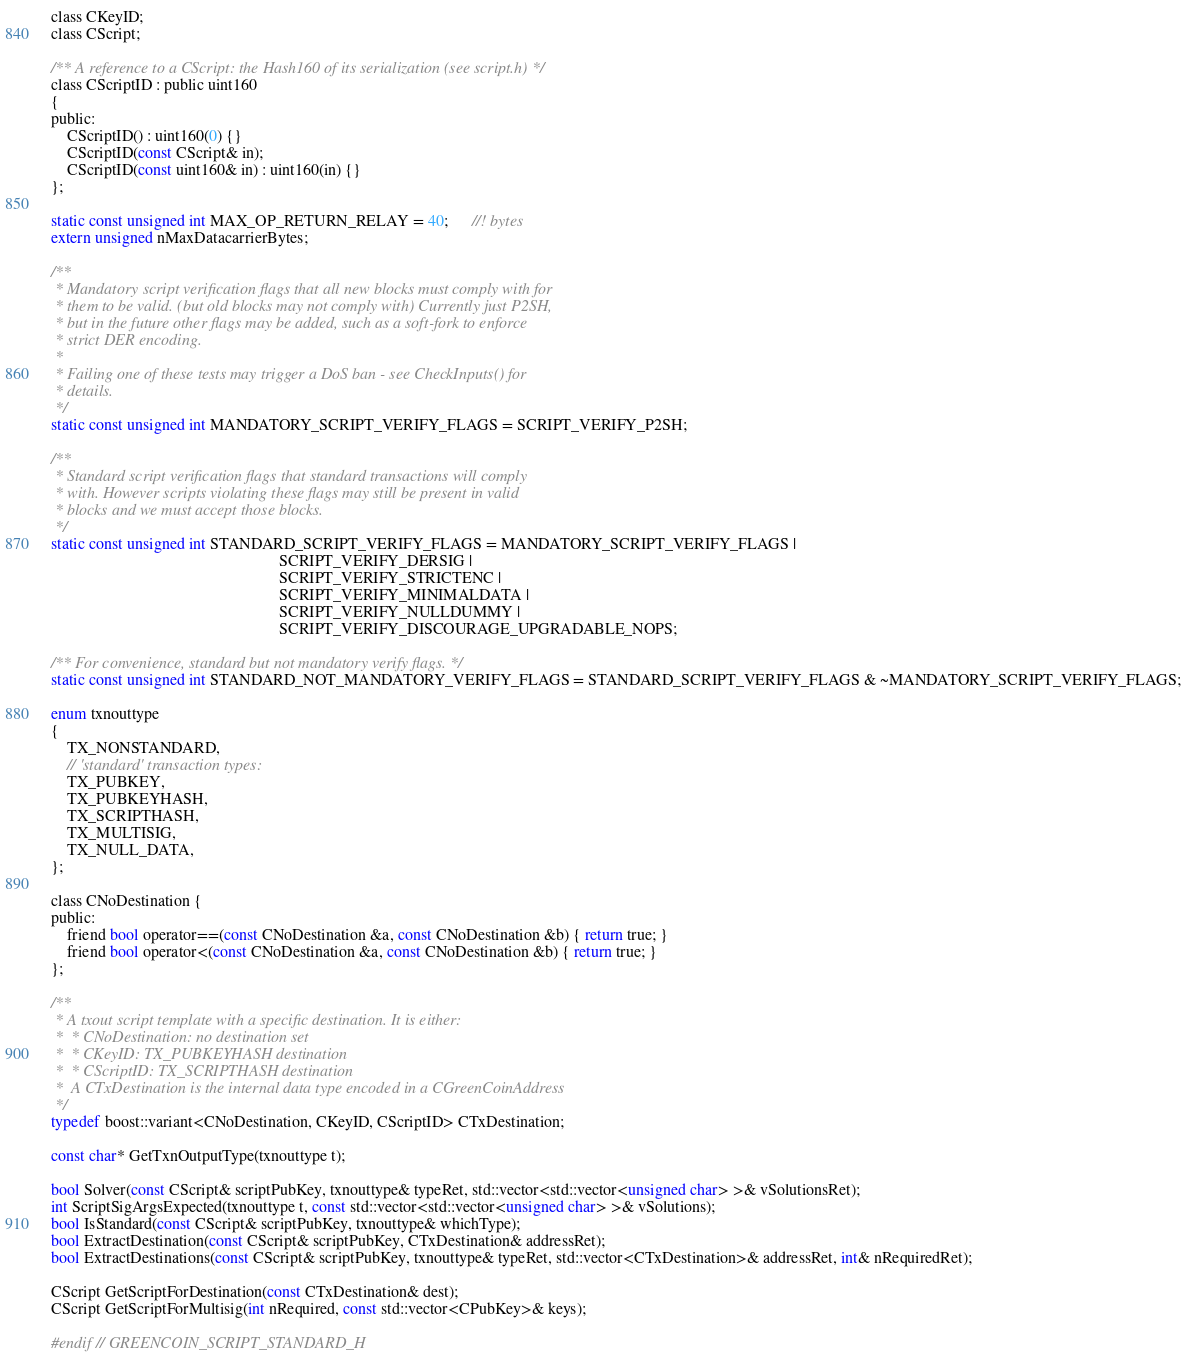Convert code to text. <code><loc_0><loc_0><loc_500><loc_500><_C_>
class CKeyID;
class CScript;

/** A reference to a CScript: the Hash160 of its serialization (see script.h) */
class CScriptID : public uint160
{
public:
    CScriptID() : uint160(0) {}
    CScriptID(const CScript& in);
    CScriptID(const uint160& in) : uint160(in) {}
};

static const unsigned int MAX_OP_RETURN_RELAY = 40;      //! bytes
extern unsigned nMaxDatacarrierBytes;

/**
 * Mandatory script verification flags that all new blocks must comply with for
 * them to be valid. (but old blocks may not comply with) Currently just P2SH,
 * but in the future other flags may be added, such as a soft-fork to enforce
 * strict DER encoding.
 * 
 * Failing one of these tests may trigger a DoS ban - see CheckInputs() for
 * details.
 */
static const unsigned int MANDATORY_SCRIPT_VERIFY_FLAGS = SCRIPT_VERIFY_P2SH;

/**
 * Standard script verification flags that standard transactions will comply
 * with. However scripts violating these flags may still be present in valid
 * blocks and we must accept those blocks.
 */
static const unsigned int STANDARD_SCRIPT_VERIFY_FLAGS = MANDATORY_SCRIPT_VERIFY_FLAGS |
                                                         SCRIPT_VERIFY_DERSIG |
                                                         SCRIPT_VERIFY_STRICTENC |
                                                         SCRIPT_VERIFY_MINIMALDATA |
                                                         SCRIPT_VERIFY_NULLDUMMY |
                                                         SCRIPT_VERIFY_DISCOURAGE_UPGRADABLE_NOPS;

/** For convenience, standard but not mandatory verify flags. */
static const unsigned int STANDARD_NOT_MANDATORY_VERIFY_FLAGS = STANDARD_SCRIPT_VERIFY_FLAGS & ~MANDATORY_SCRIPT_VERIFY_FLAGS;

enum txnouttype
{
    TX_NONSTANDARD,
    // 'standard' transaction types:
    TX_PUBKEY,
    TX_PUBKEYHASH,
    TX_SCRIPTHASH,
    TX_MULTISIG,
    TX_NULL_DATA,
};

class CNoDestination {
public:
    friend bool operator==(const CNoDestination &a, const CNoDestination &b) { return true; }
    friend bool operator<(const CNoDestination &a, const CNoDestination &b) { return true; }
};

/** 
 * A txout script template with a specific destination. It is either:
 *  * CNoDestination: no destination set
 *  * CKeyID: TX_PUBKEYHASH destination
 *  * CScriptID: TX_SCRIPTHASH destination
 *  A CTxDestination is the internal data type encoded in a CGreenCoinAddress
 */
typedef boost::variant<CNoDestination, CKeyID, CScriptID> CTxDestination;

const char* GetTxnOutputType(txnouttype t);

bool Solver(const CScript& scriptPubKey, txnouttype& typeRet, std::vector<std::vector<unsigned char> >& vSolutionsRet);
int ScriptSigArgsExpected(txnouttype t, const std::vector<std::vector<unsigned char> >& vSolutions);
bool IsStandard(const CScript& scriptPubKey, txnouttype& whichType);
bool ExtractDestination(const CScript& scriptPubKey, CTxDestination& addressRet);
bool ExtractDestinations(const CScript& scriptPubKey, txnouttype& typeRet, std::vector<CTxDestination>& addressRet, int& nRequiredRet);

CScript GetScriptForDestination(const CTxDestination& dest);
CScript GetScriptForMultisig(int nRequired, const std::vector<CPubKey>& keys);

#endif // GREENCOIN_SCRIPT_STANDARD_H
</code> 